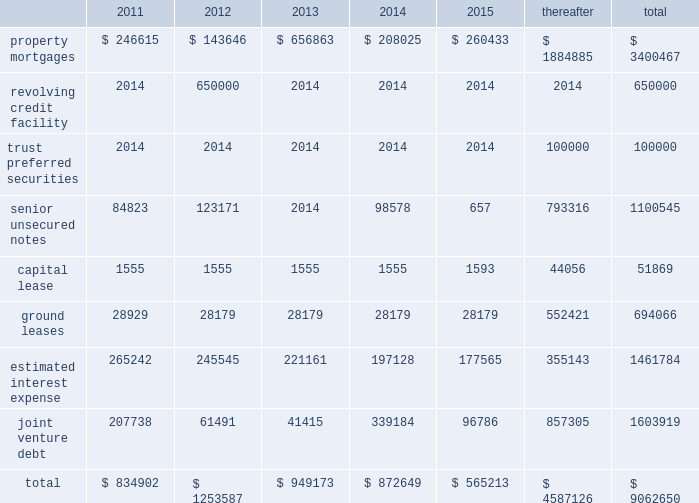Off-balance-sheet arrangements we have a number of off-balance-sheet investments , including joint ven- tures and debt and preferred equity investments .
These investments all have varying ownership structures .
Substantially all of our joint venture arrangements are accounted for under the equity method of accounting as we have the ability to exercise significant influence , but not control over the operating and financial decisions of these joint venture arrange- ments .
Our off-balance-sheet arrangements are discussed in note a0 5 , 201cdebt and preferred equity investments 201d and note a0 6 , 201cinvestments in unconsolidated joint ventures 201d in the accompanying consolidated finan- cial statements .
Additional information about the debt of our unconsoli- dated joint ventures is included in 201ccontractual obligations 201d below .
Capital expenditures we estimate that , for the year ending december a031 , 2011 , we will incur approximately $ 120.5 a0 million of capital expenditures , which are net of loan reserves ( including tenant improvements and leasing commis- sions ) , on existing wholly-owned properties , and that our share of capital expenditures at our joint venture properties , net of loan reserves , will be approximately $ 23.4 a0million .
We expect to fund these capital expen- ditures with operating cash flow , additional property level mortgage financings and cash on hand .
Future property acquisitions may require substantial capital investments for refurbishment and leasing costs .
We expect that these financing requirements will be met in a similar fashion .
We believe that we will have sufficient resources to satisfy our capital needs during the next 12-month period .
Thereafter , we expect our capital needs will be met through a combination of cash on hand , net cash provided by operations , borrowings , potential asset sales or addi- tional equity or debt issuances .
Above provides that , except to enable us to continue to qualify as a reit for federal income tax purposes , we will not during any four consecu- tive fiscal quarters make distributions with respect to common stock or other equity interests in an aggregate amount in excess of 95% ( 95 % ) of funds from operations for such period , subject to certain other adjustments .
As of december a0 31 , 2010 and 2009 , we were in compliance with all such covenants .
Market rate risk we are exposed to changes in interest rates primarily from our floating rate borrowing arrangements .
We use interest rate derivative instruments to manage exposure to interest rate changes .
A hypothetical 100 basis point increase in interest rates along the entire interest rate curve for 2010 and 2009 , would increase our annual interest cost by approximately $ 11.0 a0mil- lion and $ 15.2 a0million and would increase our share of joint venture annual interest cost by approximately $ 6.7 a0million and $ 6.4 a0million , respectively .
We recognize all derivatives on the balance sheet at fair value .
Derivatives that are not hedges must be adjusted to fair value through income .
If a derivative is a hedge , depending on the nature of the hedge , changes in the fair value of the derivative will either be offset against the change in fair value of the hedged asset , liability , or firm commitment through earnings , or recognized in other comprehensive income until the hedged item is recognized in earnings .
The ineffective portion of a deriva- tive 2019s change in fair value is recognized immediately in earnings .
Approximately $ 4.1 a0billion of our long-term debt bore interest at fixed rates , and therefore the fair value of these instruments is affected by changes in the market interest rates .
The interest rate on our variable rate debt and joint venture debt as of december a031 , 2010 ranged from libor plus 75 basis points to libor plus 400 basis points .
Contractual obligations combined aggregate principal maturities of mortgages and other loans payable , our 2007 unsecured revolving credit facility , senior unsecured notes ( net of discount ) , trust preferred securities , our share of joint venture debt , including as-of-right extension options , estimated interest expense ( based on weighted average interest rates for the quarter ) , and our obligations under our capital and ground leases , as of december a031 , 2010 , are as follows ( in thousands ) : .
48 sl green realty corp .
2010 annual report management 2019s discussion and analysis of financial condition and results of operations .
What was the total liability in millions for capital lease and ground leases? 
Computations: (51869 + 694066)
Answer: 745935.0. 